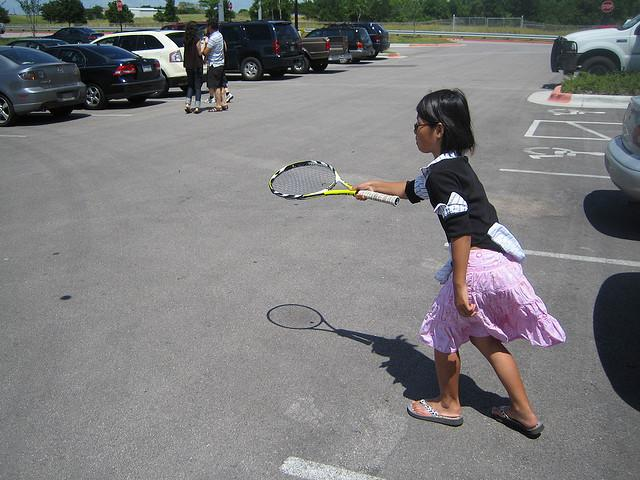Who plays the same sport?

Choices:
A) serena williams
B) otis nixon
C) alex morgan
D) danica patrick serena williams 